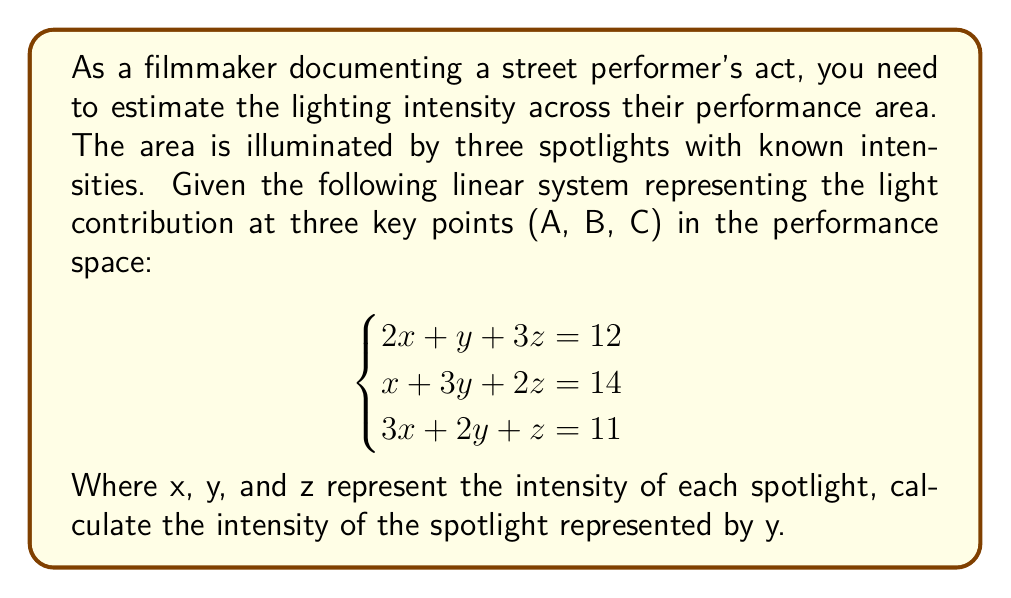Can you solve this math problem? To solve this linear system, we'll use Cramer's rule:

1) First, calculate the determinant of the coefficient matrix:
   $$\begin{vmatrix}
   2 & 1 & 3 \\
   1 & 3 & 2 \\
   3 & 2 & 1
   \end{vmatrix} = 2(3-4) + 1(2-9) + 3(3-6) = -2 - 7 - 9 = -18$$

2) Now, calculate the determinant for y by replacing the second column with the constants:
   $$\begin{vmatrix}
   2 & 12 & 3 \\
   1 & 14 & 2 \\
   3 & 11 & 1
   \end{vmatrix} = 2(14-33) + 12(2-3) + 3(11-42) = -38 - 12 - 93 = -143$$

3) Apply Cramer's rule to find y:
   $$y = \frac{\begin{vmatrix}
   2 & 12 & 3 \\
   1 & 14 & 2 \\
   3 & 11 & 1
   \end{vmatrix}}{\begin{vmatrix}
   2 & 1 & 3 \\
   1 & 3 & 2 \\
   3 & 2 & 1
   \end{vmatrix}} = \frac{-143}{-18} = \frac{143}{18} \approx 7.94$$

Therefore, the intensity of the spotlight represented by y is approximately 7.94 units.
Answer: $\frac{143}{18}$ or approximately 7.94 